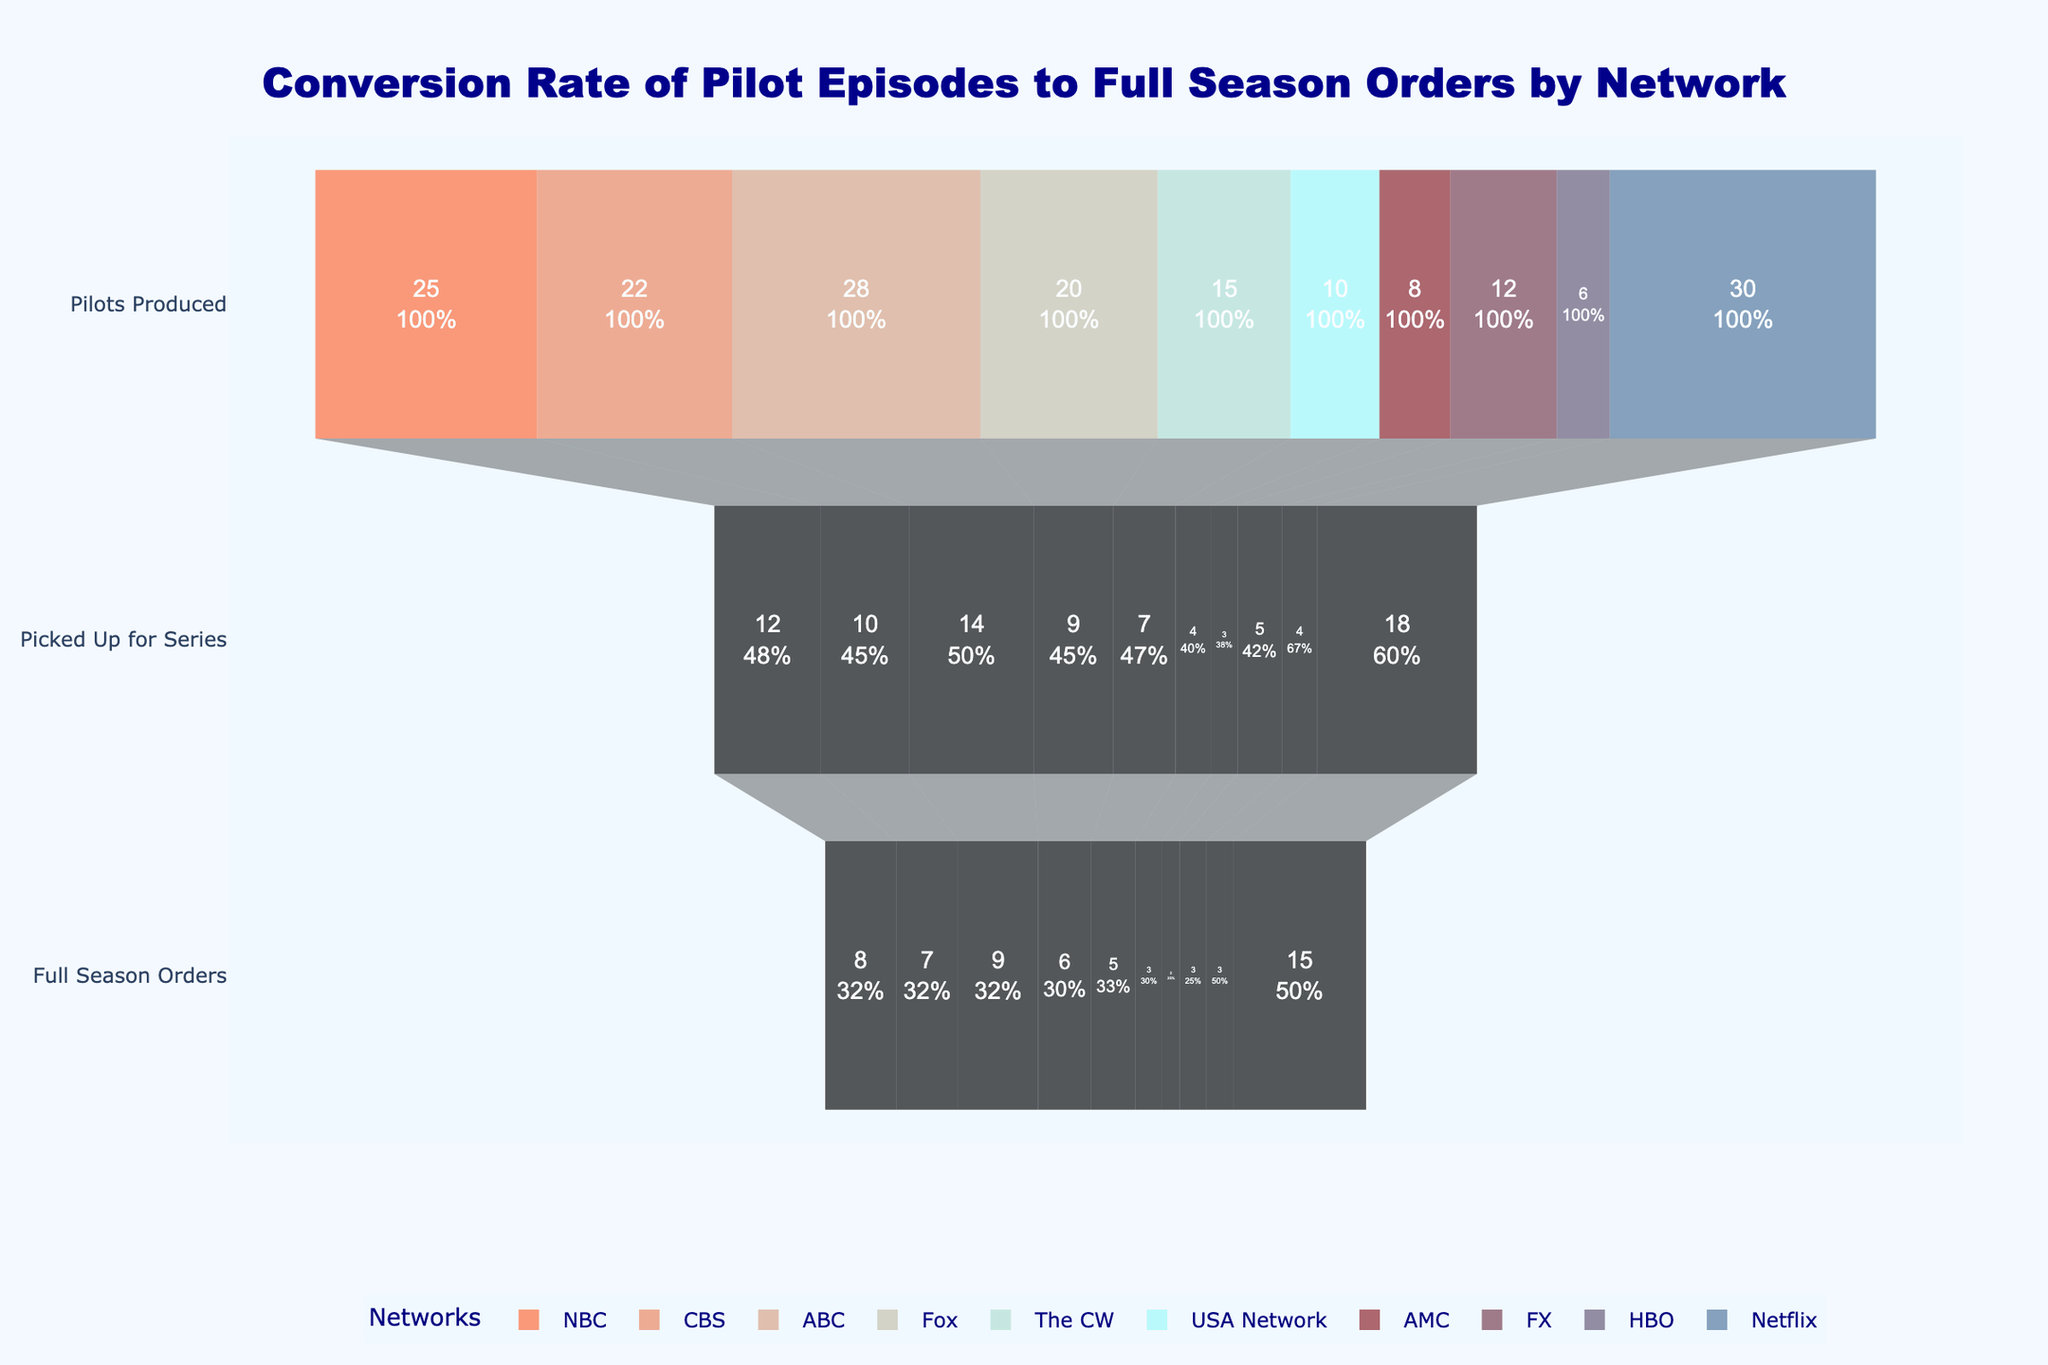What is the title of the funnel chart? The title is displayed prominently at the top of the chart. It reads, "Conversion Rate of Pilot Episodes to Full Season Orders by Network."
Answer: Conversion Rate of Pilot Episodes to Full Season Orders by Network Which network produced the most pilots? The height of the first stage of the funnel (Pilots Produced) for each network visually shows the values. The tallest bar in this stage is for Netflix, with 30 pilots produced.
Answer: Netflix How many NBC pilots were picked up for a full season order? Trace the stages for NBC from Pilots Produced to Picked Up for Series to Full Season Orders. For Full Season Orders, NBC has 8.
Answer: 8 What is the conversion rate from pilots produced to pilots picked up for a full season for CBS? Conversion rate is calculated by dividing the number of full season orders by the number of pilots produced. For CBS, it is 7 full season orders out of 22 pilots produced, so 7/22 = 0.318 or 31.8%.
Answer: 31.8% Which network has the highest conversion from picked up pilots to full season orders? This requires calculating the ratio of Full Season Orders to Picked Up for Series for each network. For Netflix: 15/18 = 83.3%, demonstrating the highest conversion rate.
Answer: Netflix How does HBO's pick-up rate compare to AMC's pick-up rate? Pick-up rate is the ratio of pilots picked up for series to pilots produced. For HBO: 4/6 = 66.7%, and for AMC: 3/8 = 37.5%. HBO's pick-up rate is higher than AMC's.
Answer: HBO > AMC Which stages show the largest drop in pilot numbers for ABC? Compare the number of pilots in each stage for ABC. From Pilots Produced (28) to Picked Up for Series (14), there's a drop of 14 pilots. From Picked Up for Series to Full Season Orders (9), there's a drop of 5 pilots. The largest drop is in the first transition.
Answer: Pilots Produced to Picked Up for Series Identify the networks with less than 10 pilots picked up for series. Count the networks where the second stage (Picked Up for Series) has values less than 10. NBC (12), CBS (10), Fox (9), The CW (7), USA Network (4), AMC (3), FX (5), HBO (4). Excluding NBC, CBS, and ABC leaves Fox, The CW, USA Network, AMC, FX, and HBO.
Answer: Fox, The CW, USA Network, AMC, FX, HBO What is the total number of pilots produced by all networks combined? Sum the Pilots Produced values for all networks: 25 + 22 + 28 + 20 + 15 + 10 + 8 + 12 + 6 + 30 = 176.
Answer: 176 